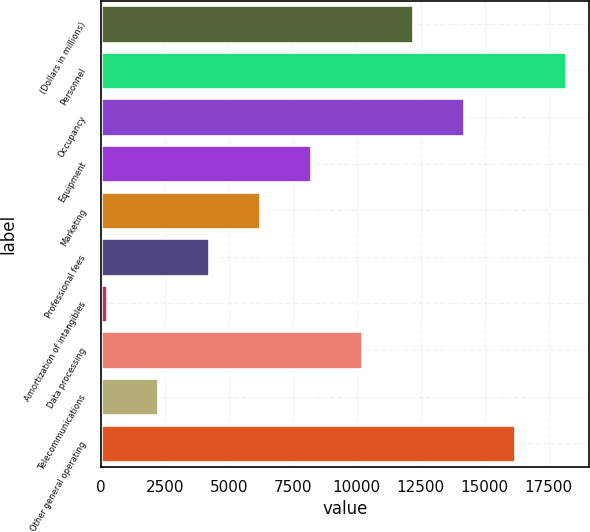<chart> <loc_0><loc_0><loc_500><loc_500><bar_chart><fcel>(Dollars in millions)<fcel>Personnel<fcel>Occupancy<fcel>Equipment<fcel>Marketing<fcel>Professional fees<fcel>Amortization of intangibles<fcel>Data processing<fcel>Telecommunications<fcel>Other general operating<nl><fcel>12179.8<fcel>18161.2<fcel>14173.6<fcel>8192.2<fcel>6198.4<fcel>4204.6<fcel>217<fcel>10186<fcel>2210.8<fcel>16167.4<nl></chart> 